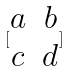Convert formula to latex. <formula><loc_0><loc_0><loc_500><loc_500>[ \begin{matrix} a & b \\ c & d \\ \end{matrix} ]</formula> 